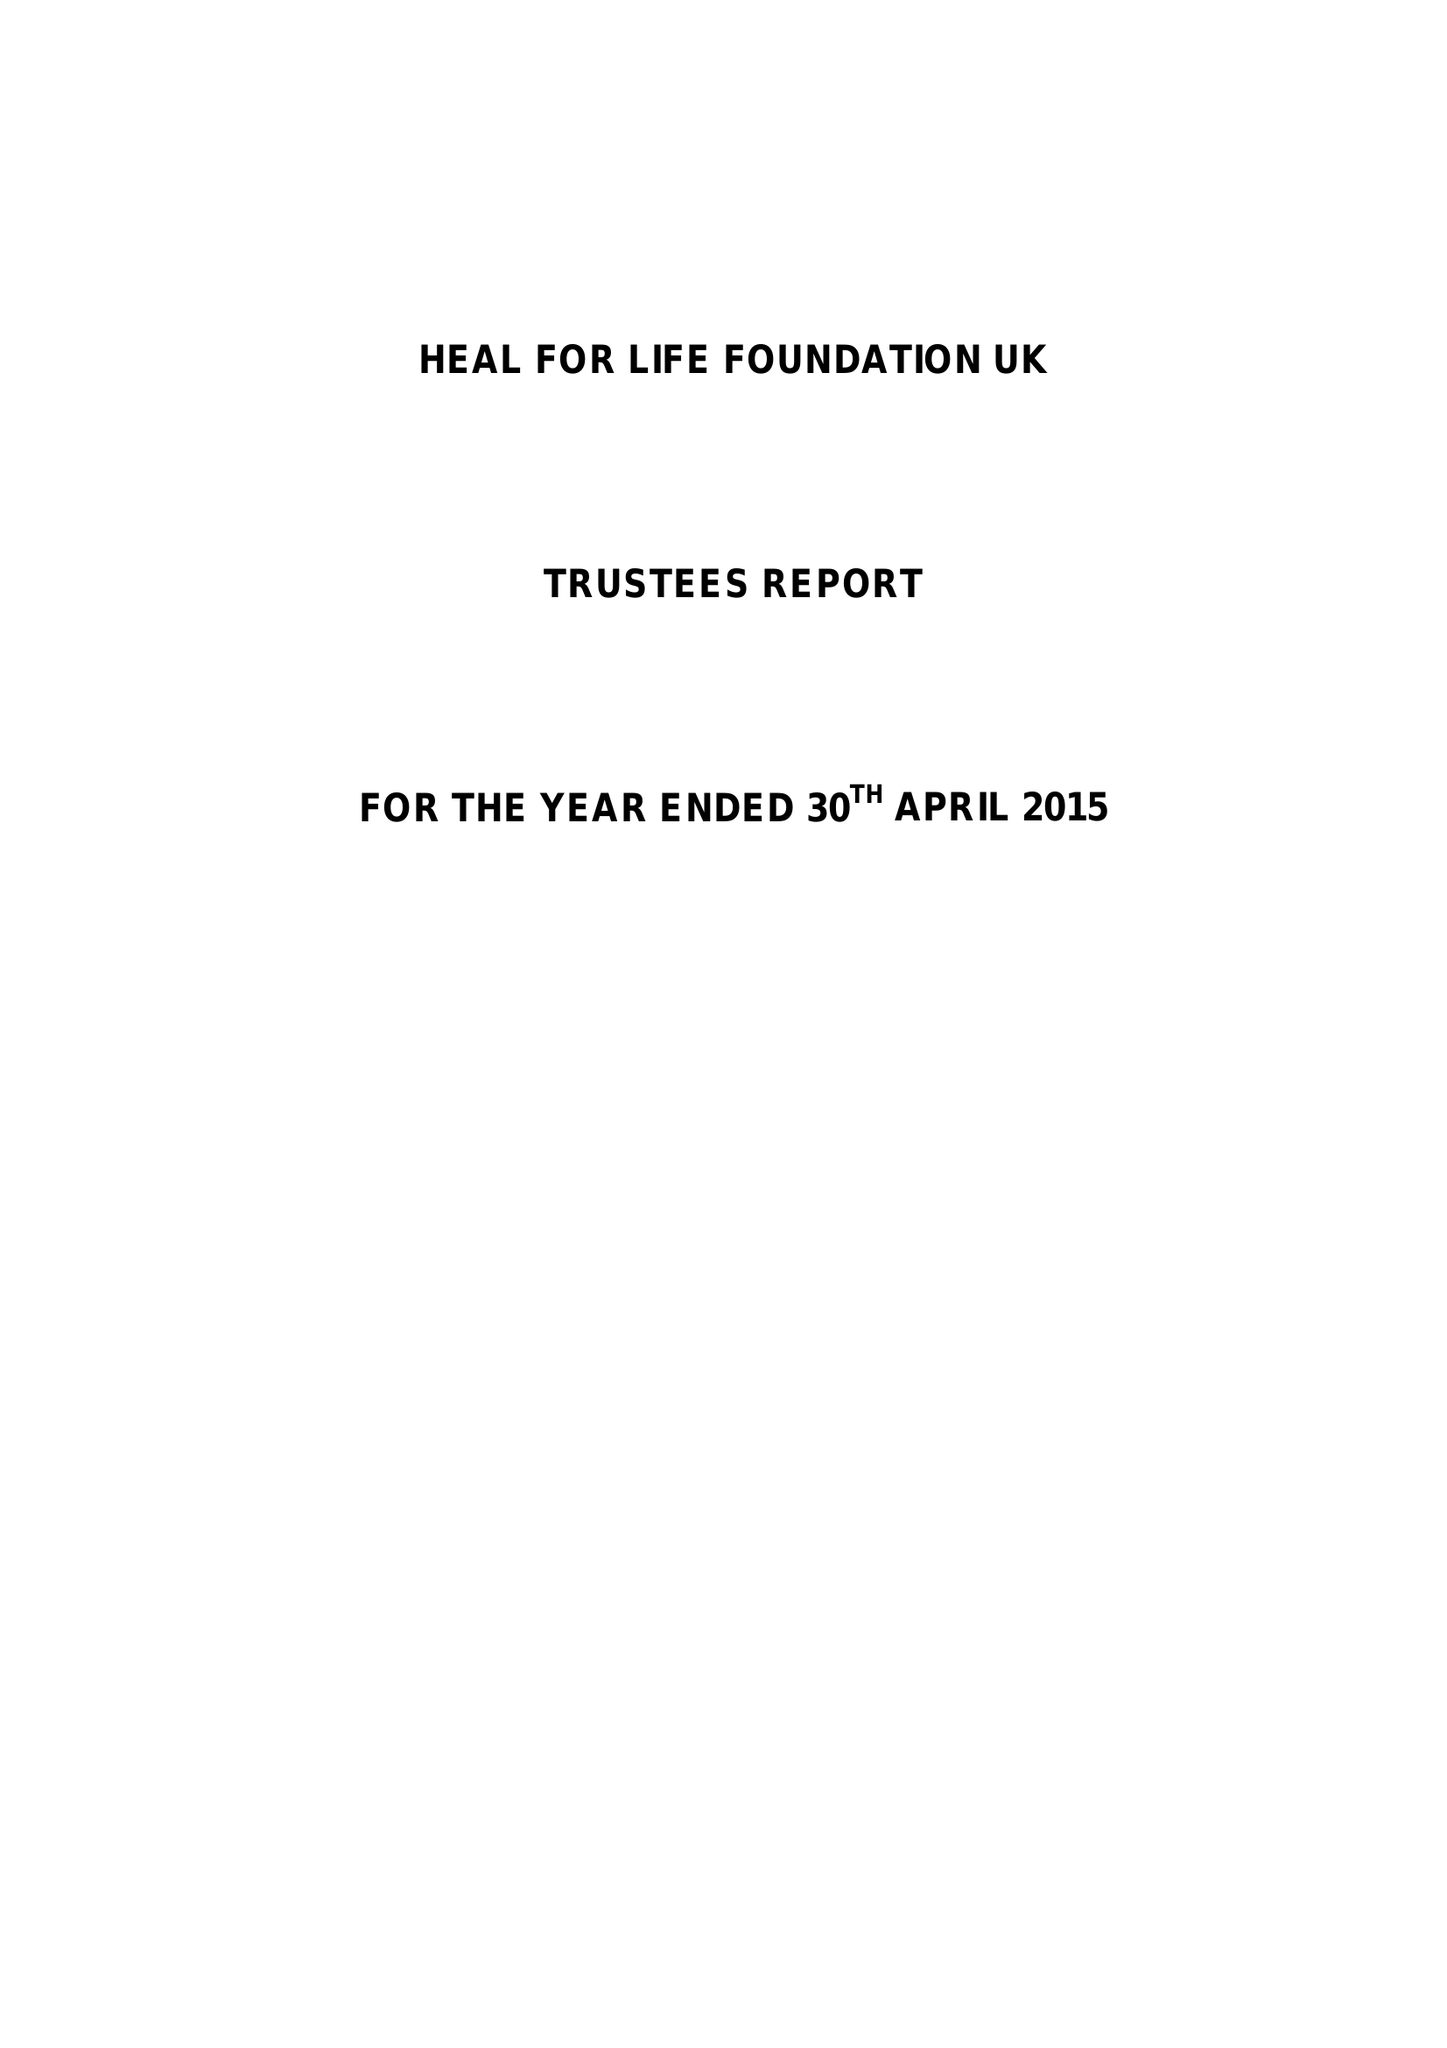What is the value for the address__street_line?
Answer the question using a single word or phrase. 24 CHURCH STREET 